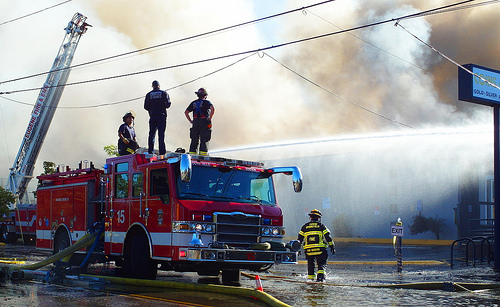<image>
Can you confirm if the man is on the fire truck? Yes. Looking at the image, I can see the man is positioned on top of the fire truck, with the fire truck providing support. 